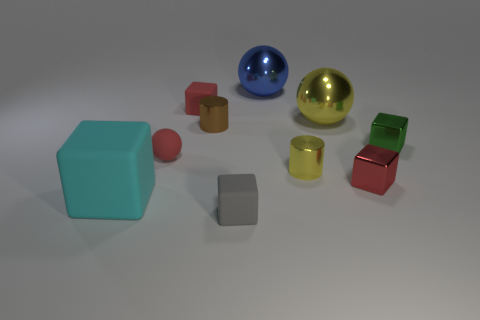Do the cyan block and the red block that is right of the gray matte object have the same size?
Your answer should be compact. No. How many cubes are small yellow things or big shiny objects?
Offer a terse response. 0. How many small blocks are both to the left of the red metal object and behind the red shiny thing?
Ensure brevity in your answer.  1. How many other objects are the same color as the tiny ball?
Your answer should be compact. 2. There is a object that is right of the tiny red metallic cube; what is its shape?
Offer a terse response. Cube. Is the material of the yellow cylinder the same as the red ball?
Your answer should be very brief. No. Are there any other things that are the same size as the green metallic block?
Provide a succinct answer. Yes. What number of shiny objects are in front of the gray object?
Provide a short and direct response. 0. What is the shape of the red thing that is in front of the ball to the left of the large blue shiny sphere?
Offer a very short reply. Cube. Is there anything else that has the same shape as the small brown shiny thing?
Ensure brevity in your answer.  Yes. 